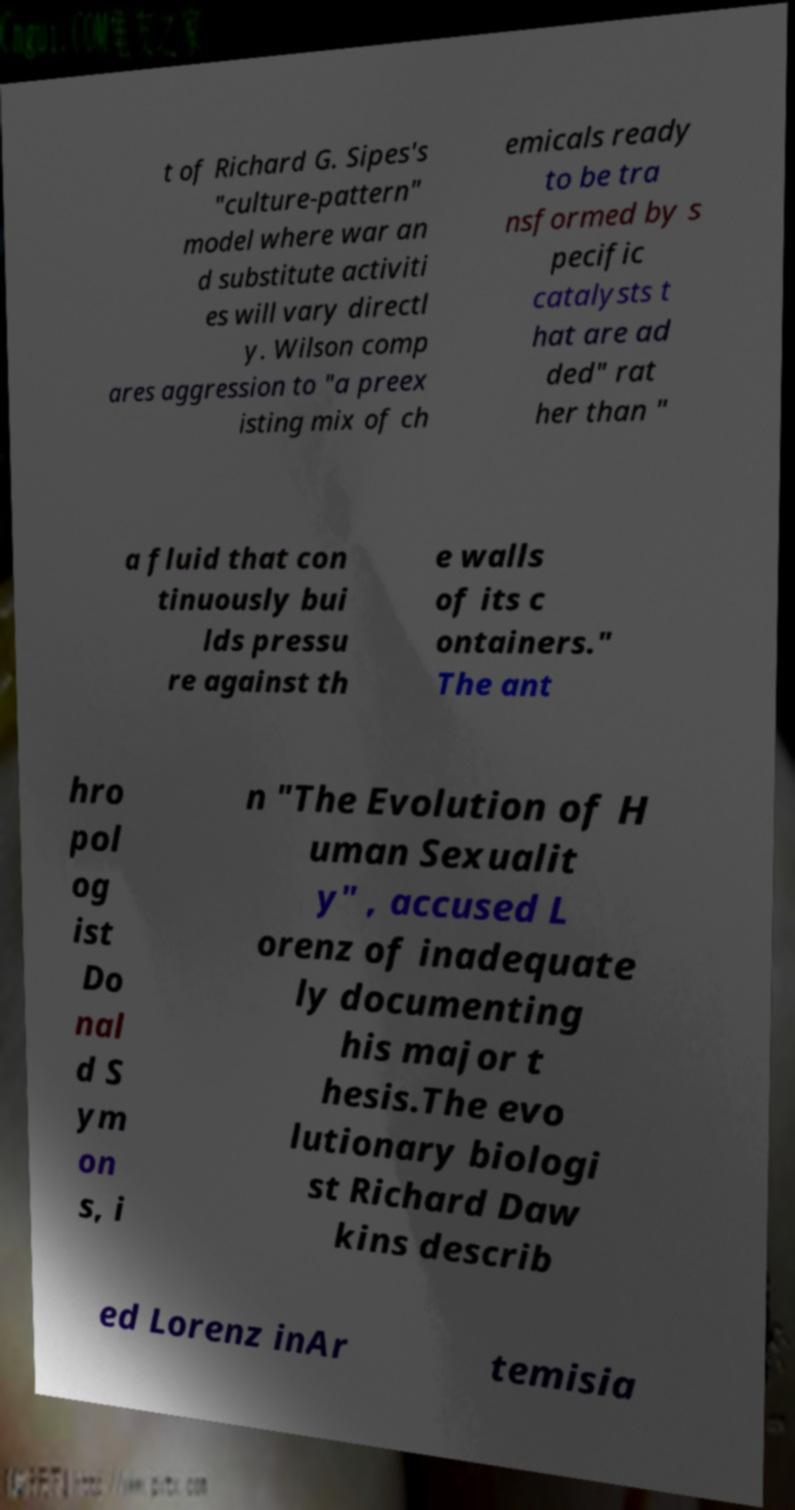Could you assist in decoding the text presented in this image and type it out clearly? t of Richard G. Sipes's "culture-pattern" model where war an d substitute activiti es will vary directl y. Wilson comp ares aggression to "a preex isting mix of ch emicals ready to be tra nsformed by s pecific catalysts t hat are ad ded" rat her than " a fluid that con tinuously bui lds pressu re against th e walls of its c ontainers." The ant hro pol og ist Do nal d S ym on s, i n "The Evolution of H uman Sexualit y" , accused L orenz of inadequate ly documenting his major t hesis.The evo lutionary biologi st Richard Daw kins describ ed Lorenz inAr temisia 